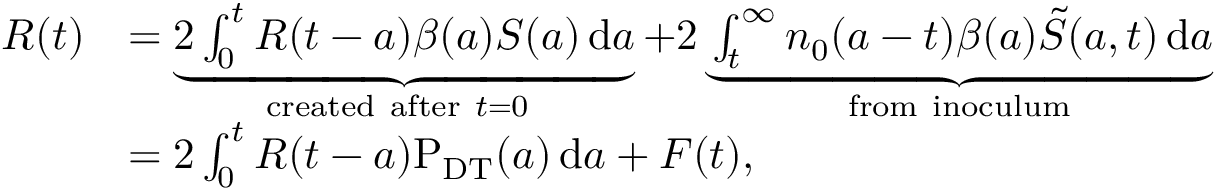<formula> <loc_0><loc_0><loc_500><loc_500>\begin{array} { r l } { R ( t ) } & { = \underbrace { 2 \int _ { 0 } ^ { t } { R ( t - a ) \beta ( a ) S ( a ) \, d a } } _ { c r e a t e d a f t e r t = 0 } + 2 \underbrace { \int _ { t } ^ { \infty } { { { n } _ { 0 } } ( a - t ) \beta ( a ) \tilde { S } ( { a , t } ) \, d a } } _ { f r o m i n o c u l u m } } \\ & { = 2 \int _ { 0 } ^ { t } { R ( t - a ) P _ { D T } ( a ) \, d a } + F ( t ) , } \end{array}</formula> 